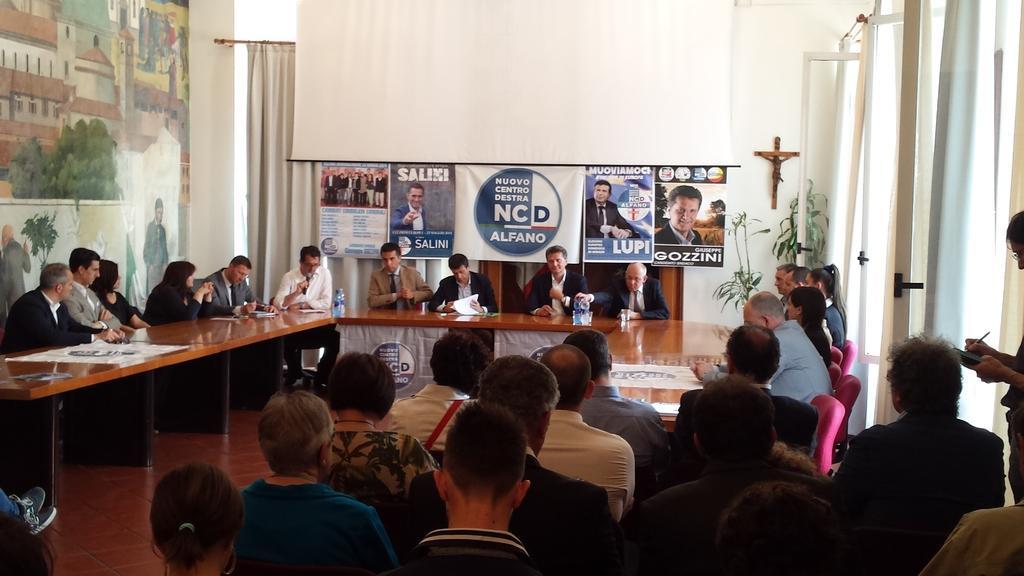In one or two sentences, can you explain what this image depicts? In this image, group of people sitting on the chair in front of the table on which bottle, papers are kept. At the bottom, group of people sitting on the chair. The background is white in color on which a wall painting is there. And a curtain of light brown in color visible. On the right, windows are visible. This image is taken inside a hall. 